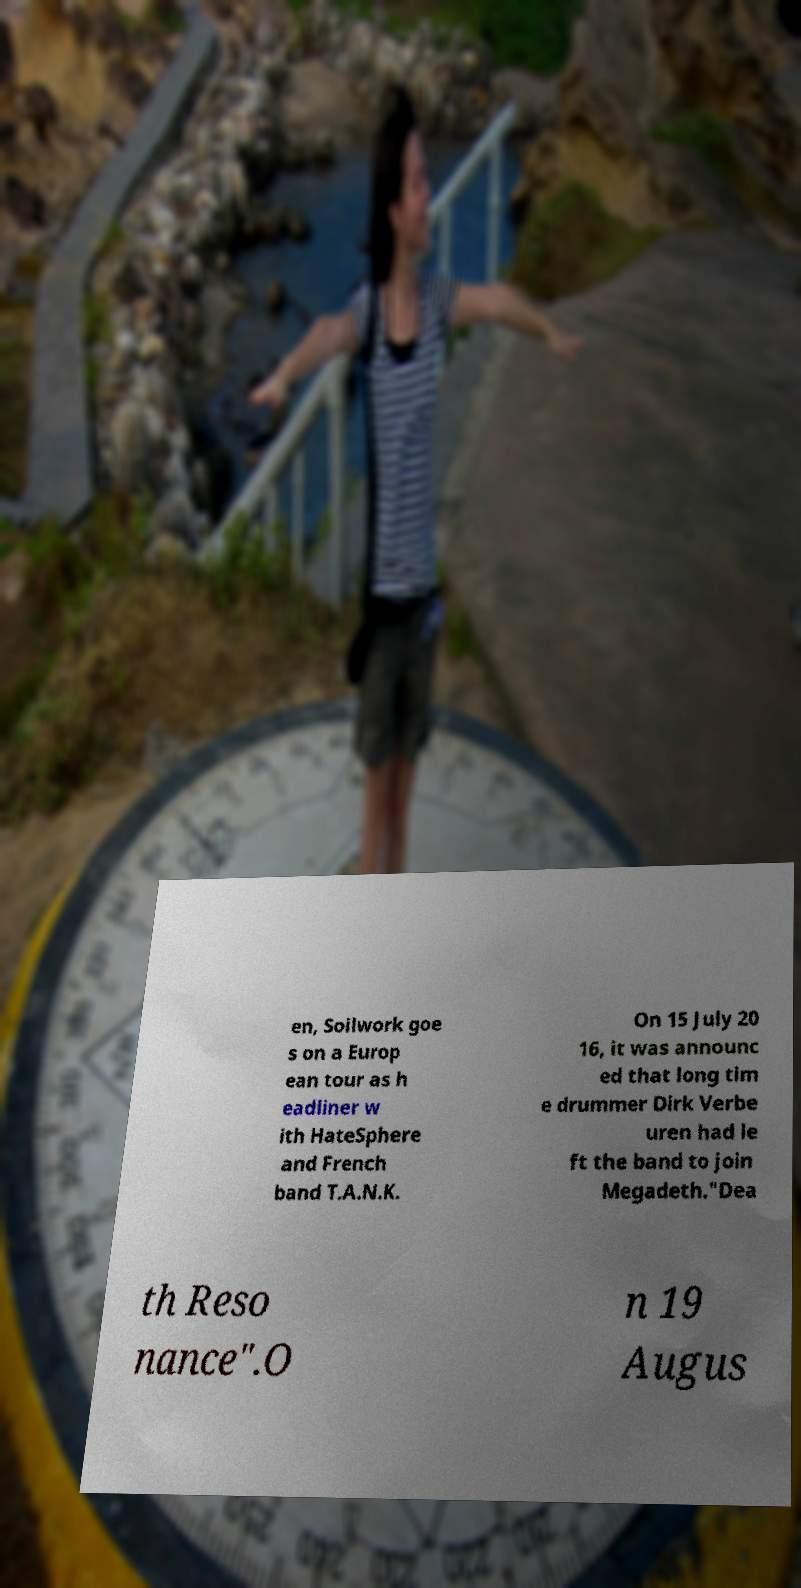There's text embedded in this image that I need extracted. Can you transcribe it verbatim? en, Soilwork goe s on a Europ ean tour as h eadliner w ith HateSphere and French band T.A.N.K. On 15 July 20 16, it was announc ed that long tim e drummer Dirk Verbe uren had le ft the band to join Megadeth."Dea th Reso nance".O n 19 Augus 